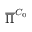Convert formula to latex. <formula><loc_0><loc_0><loc_500><loc_500>\overline { \Pi } ^ { C _ { 0 } }</formula> 